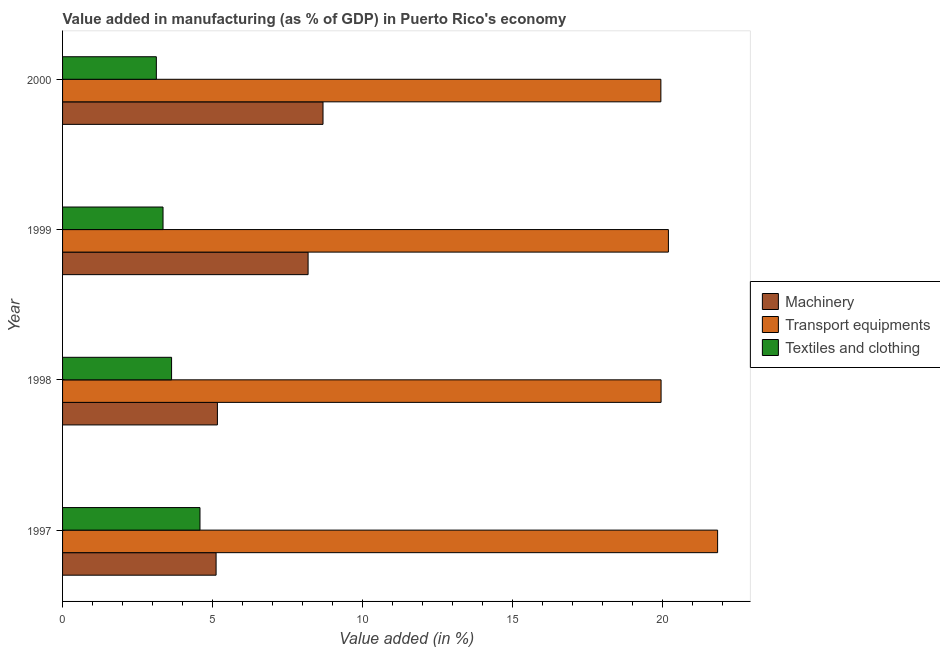How many different coloured bars are there?
Keep it short and to the point. 3. How many groups of bars are there?
Offer a very short reply. 4. How many bars are there on the 3rd tick from the bottom?
Provide a short and direct response. 3. What is the label of the 1st group of bars from the top?
Your answer should be compact. 2000. In how many cases, is the number of bars for a given year not equal to the number of legend labels?
Give a very brief answer. 0. What is the value added in manufacturing transport equipments in 1999?
Provide a succinct answer. 20.2. Across all years, what is the maximum value added in manufacturing transport equipments?
Provide a short and direct response. 21.84. Across all years, what is the minimum value added in manufacturing textile and clothing?
Make the answer very short. 3.13. In which year was the value added in manufacturing transport equipments minimum?
Keep it short and to the point. 2000. What is the total value added in manufacturing textile and clothing in the graph?
Make the answer very short. 14.69. What is the difference between the value added in manufacturing transport equipments in 1997 and that in 2000?
Offer a terse response. 1.89. What is the difference between the value added in manufacturing transport equipments in 1999 and the value added in manufacturing textile and clothing in 1998?
Provide a short and direct response. 16.56. What is the average value added in manufacturing transport equipments per year?
Provide a short and direct response. 20.48. In the year 1998, what is the difference between the value added in manufacturing transport equipments and value added in manufacturing textile and clothing?
Provide a succinct answer. 16.32. In how many years, is the value added in manufacturing textile and clothing greater than 12 %?
Your answer should be compact. 0. What is the ratio of the value added in manufacturing transport equipments in 1997 to that in 1999?
Your response must be concise. 1.08. What is the difference between the highest and the second highest value added in manufacturing machinery?
Your response must be concise. 0.5. What is the difference between the highest and the lowest value added in manufacturing machinery?
Your answer should be very brief. 3.56. In how many years, is the value added in manufacturing textile and clothing greater than the average value added in manufacturing textile and clothing taken over all years?
Provide a short and direct response. 1. Is the sum of the value added in manufacturing transport equipments in 1998 and 1999 greater than the maximum value added in manufacturing textile and clothing across all years?
Provide a succinct answer. Yes. What does the 2nd bar from the top in 1999 represents?
Give a very brief answer. Transport equipments. What does the 3rd bar from the bottom in 1999 represents?
Offer a very short reply. Textiles and clothing. Does the graph contain any zero values?
Provide a succinct answer. No. Does the graph contain grids?
Offer a very short reply. No. How many legend labels are there?
Ensure brevity in your answer.  3. What is the title of the graph?
Give a very brief answer. Value added in manufacturing (as % of GDP) in Puerto Rico's economy. What is the label or title of the X-axis?
Offer a very short reply. Value added (in %). What is the Value added (in %) of Machinery in 1997?
Your answer should be very brief. 5.12. What is the Value added (in %) of Transport equipments in 1997?
Make the answer very short. 21.84. What is the Value added (in %) of Textiles and clothing in 1997?
Give a very brief answer. 4.58. What is the Value added (in %) of Machinery in 1998?
Offer a terse response. 5.16. What is the Value added (in %) of Transport equipments in 1998?
Your answer should be very brief. 19.95. What is the Value added (in %) in Textiles and clothing in 1998?
Give a very brief answer. 3.63. What is the Value added (in %) in Machinery in 1999?
Your response must be concise. 8.19. What is the Value added (in %) in Transport equipments in 1999?
Offer a very short reply. 20.2. What is the Value added (in %) in Textiles and clothing in 1999?
Provide a short and direct response. 3.35. What is the Value added (in %) of Machinery in 2000?
Offer a very short reply. 8.68. What is the Value added (in %) in Transport equipments in 2000?
Make the answer very short. 19.95. What is the Value added (in %) in Textiles and clothing in 2000?
Your answer should be very brief. 3.13. Across all years, what is the maximum Value added (in %) of Machinery?
Make the answer very short. 8.68. Across all years, what is the maximum Value added (in %) of Transport equipments?
Keep it short and to the point. 21.84. Across all years, what is the maximum Value added (in %) of Textiles and clothing?
Keep it short and to the point. 4.58. Across all years, what is the minimum Value added (in %) of Machinery?
Make the answer very short. 5.12. Across all years, what is the minimum Value added (in %) in Transport equipments?
Your answer should be compact. 19.95. Across all years, what is the minimum Value added (in %) of Textiles and clothing?
Provide a succinct answer. 3.13. What is the total Value added (in %) of Machinery in the graph?
Offer a terse response. 27.15. What is the total Value added (in %) in Transport equipments in the graph?
Offer a very short reply. 81.94. What is the total Value added (in %) in Textiles and clothing in the graph?
Provide a succinct answer. 14.69. What is the difference between the Value added (in %) in Machinery in 1997 and that in 1998?
Give a very brief answer. -0.04. What is the difference between the Value added (in %) in Transport equipments in 1997 and that in 1998?
Keep it short and to the point. 1.88. What is the difference between the Value added (in %) in Textiles and clothing in 1997 and that in 1998?
Your answer should be very brief. 0.95. What is the difference between the Value added (in %) in Machinery in 1997 and that in 1999?
Provide a succinct answer. -3.07. What is the difference between the Value added (in %) in Transport equipments in 1997 and that in 1999?
Ensure brevity in your answer.  1.64. What is the difference between the Value added (in %) of Textiles and clothing in 1997 and that in 1999?
Give a very brief answer. 1.23. What is the difference between the Value added (in %) in Machinery in 1997 and that in 2000?
Ensure brevity in your answer.  -3.56. What is the difference between the Value added (in %) in Transport equipments in 1997 and that in 2000?
Ensure brevity in your answer.  1.89. What is the difference between the Value added (in %) of Textiles and clothing in 1997 and that in 2000?
Provide a short and direct response. 1.46. What is the difference between the Value added (in %) of Machinery in 1998 and that in 1999?
Keep it short and to the point. -3.02. What is the difference between the Value added (in %) in Transport equipments in 1998 and that in 1999?
Your answer should be compact. -0.24. What is the difference between the Value added (in %) in Textiles and clothing in 1998 and that in 1999?
Your answer should be very brief. 0.28. What is the difference between the Value added (in %) of Machinery in 1998 and that in 2000?
Give a very brief answer. -3.52. What is the difference between the Value added (in %) of Transport equipments in 1998 and that in 2000?
Make the answer very short. 0.01. What is the difference between the Value added (in %) in Textiles and clothing in 1998 and that in 2000?
Make the answer very short. 0.51. What is the difference between the Value added (in %) of Machinery in 1999 and that in 2000?
Your answer should be very brief. -0.5. What is the difference between the Value added (in %) in Transport equipments in 1999 and that in 2000?
Your response must be concise. 0.25. What is the difference between the Value added (in %) of Textiles and clothing in 1999 and that in 2000?
Offer a terse response. 0.22. What is the difference between the Value added (in %) of Machinery in 1997 and the Value added (in %) of Transport equipments in 1998?
Ensure brevity in your answer.  -14.84. What is the difference between the Value added (in %) in Machinery in 1997 and the Value added (in %) in Textiles and clothing in 1998?
Ensure brevity in your answer.  1.48. What is the difference between the Value added (in %) of Transport equipments in 1997 and the Value added (in %) of Textiles and clothing in 1998?
Ensure brevity in your answer.  18.2. What is the difference between the Value added (in %) in Machinery in 1997 and the Value added (in %) in Transport equipments in 1999?
Provide a succinct answer. -15.08. What is the difference between the Value added (in %) in Machinery in 1997 and the Value added (in %) in Textiles and clothing in 1999?
Provide a succinct answer. 1.77. What is the difference between the Value added (in %) of Transport equipments in 1997 and the Value added (in %) of Textiles and clothing in 1999?
Offer a very short reply. 18.49. What is the difference between the Value added (in %) in Machinery in 1997 and the Value added (in %) in Transport equipments in 2000?
Give a very brief answer. -14.83. What is the difference between the Value added (in %) in Machinery in 1997 and the Value added (in %) in Textiles and clothing in 2000?
Your answer should be very brief. 1.99. What is the difference between the Value added (in %) in Transport equipments in 1997 and the Value added (in %) in Textiles and clothing in 2000?
Ensure brevity in your answer.  18.71. What is the difference between the Value added (in %) of Machinery in 1998 and the Value added (in %) of Transport equipments in 1999?
Your answer should be very brief. -15.04. What is the difference between the Value added (in %) of Machinery in 1998 and the Value added (in %) of Textiles and clothing in 1999?
Provide a succinct answer. 1.81. What is the difference between the Value added (in %) of Transport equipments in 1998 and the Value added (in %) of Textiles and clothing in 1999?
Give a very brief answer. 16.61. What is the difference between the Value added (in %) in Machinery in 1998 and the Value added (in %) in Transport equipments in 2000?
Provide a short and direct response. -14.78. What is the difference between the Value added (in %) in Machinery in 1998 and the Value added (in %) in Textiles and clothing in 2000?
Make the answer very short. 2.04. What is the difference between the Value added (in %) in Transport equipments in 1998 and the Value added (in %) in Textiles and clothing in 2000?
Offer a terse response. 16.83. What is the difference between the Value added (in %) in Machinery in 1999 and the Value added (in %) in Transport equipments in 2000?
Keep it short and to the point. -11.76. What is the difference between the Value added (in %) in Machinery in 1999 and the Value added (in %) in Textiles and clothing in 2000?
Provide a succinct answer. 5.06. What is the difference between the Value added (in %) of Transport equipments in 1999 and the Value added (in %) of Textiles and clothing in 2000?
Offer a very short reply. 17.07. What is the average Value added (in %) in Machinery per year?
Offer a very short reply. 6.79. What is the average Value added (in %) in Transport equipments per year?
Ensure brevity in your answer.  20.48. What is the average Value added (in %) in Textiles and clothing per year?
Give a very brief answer. 3.67. In the year 1997, what is the difference between the Value added (in %) of Machinery and Value added (in %) of Transport equipments?
Keep it short and to the point. -16.72. In the year 1997, what is the difference between the Value added (in %) of Machinery and Value added (in %) of Textiles and clothing?
Make the answer very short. 0.54. In the year 1997, what is the difference between the Value added (in %) of Transport equipments and Value added (in %) of Textiles and clothing?
Your response must be concise. 17.26. In the year 1998, what is the difference between the Value added (in %) in Machinery and Value added (in %) in Transport equipments?
Your answer should be very brief. -14.79. In the year 1998, what is the difference between the Value added (in %) of Machinery and Value added (in %) of Textiles and clothing?
Your response must be concise. 1.53. In the year 1998, what is the difference between the Value added (in %) in Transport equipments and Value added (in %) in Textiles and clothing?
Provide a succinct answer. 16.32. In the year 1999, what is the difference between the Value added (in %) of Machinery and Value added (in %) of Transport equipments?
Your answer should be very brief. -12.01. In the year 1999, what is the difference between the Value added (in %) of Machinery and Value added (in %) of Textiles and clothing?
Keep it short and to the point. 4.84. In the year 1999, what is the difference between the Value added (in %) of Transport equipments and Value added (in %) of Textiles and clothing?
Your answer should be compact. 16.85. In the year 2000, what is the difference between the Value added (in %) in Machinery and Value added (in %) in Transport equipments?
Your response must be concise. -11.26. In the year 2000, what is the difference between the Value added (in %) in Machinery and Value added (in %) in Textiles and clothing?
Ensure brevity in your answer.  5.56. In the year 2000, what is the difference between the Value added (in %) of Transport equipments and Value added (in %) of Textiles and clothing?
Your answer should be compact. 16.82. What is the ratio of the Value added (in %) of Transport equipments in 1997 to that in 1998?
Your response must be concise. 1.09. What is the ratio of the Value added (in %) in Textiles and clothing in 1997 to that in 1998?
Your response must be concise. 1.26. What is the ratio of the Value added (in %) in Machinery in 1997 to that in 1999?
Ensure brevity in your answer.  0.63. What is the ratio of the Value added (in %) of Transport equipments in 1997 to that in 1999?
Your answer should be compact. 1.08. What is the ratio of the Value added (in %) in Textiles and clothing in 1997 to that in 1999?
Provide a succinct answer. 1.37. What is the ratio of the Value added (in %) in Machinery in 1997 to that in 2000?
Offer a very short reply. 0.59. What is the ratio of the Value added (in %) in Transport equipments in 1997 to that in 2000?
Provide a succinct answer. 1.09. What is the ratio of the Value added (in %) in Textiles and clothing in 1997 to that in 2000?
Provide a succinct answer. 1.47. What is the ratio of the Value added (in %) of Machinery in 1998 to that in 1999?
Offer a very short reply. 0.63. What is the ratio of the Value added (in %) of Transport equipments in 1998 to that in 1999?
Ensure brevity in your answer.  0.99. What is the ratio of the Value added (in %) in Textiles and clothing in 1998 to that in 1999?
Your response must be concise. 1.09. What is the ratio of the Value added (in %) in Machinery in 1998 to that in 2000?
Make the answer very short. 0.59. What is the ratio of the Value added (in %) in Textiles and clothing in 1998 to that in 2000?
Offer a very short reply. 1.16. What is the ratio of the Value added (in %) in Machinery in 1999 to that in 2000?
Your answer should be very brief. 0.94. What is the ratio of the Value added (in %) in Transport equipments in 1999 to that in 2000?
Make the answer very short. 1.01. What is the ratio of the Value added (in %) in Textiles and clothing in 1999 to that in 2000?
Offer a very short reply. 1.07. What is the difference between the highest and the second highest Value added (in %) of Machinery?
Provide a succinct answer. 0.5. What is the difference between the highest and the second highest Value added (in %) of Transport equipments?
Your answer should be very brief. 1.64. What is the difference between the highest and the second highest Value added (in %) in Textiles and clothing?
Make the answer very short. 0.95. What is the difference between the highest and the lowest Value added (in %) in Machinery?
Ensure brevity in your answer.  3.56. What is the difference between the highest and the lowest Value added (in %) of Transport equipments?
Ensure brevity in your answer.  1.89. What is the difference between the highest and the lowest Value added (in %) in Textiles and clothing?
Provide a short and direct response. 1.46. 